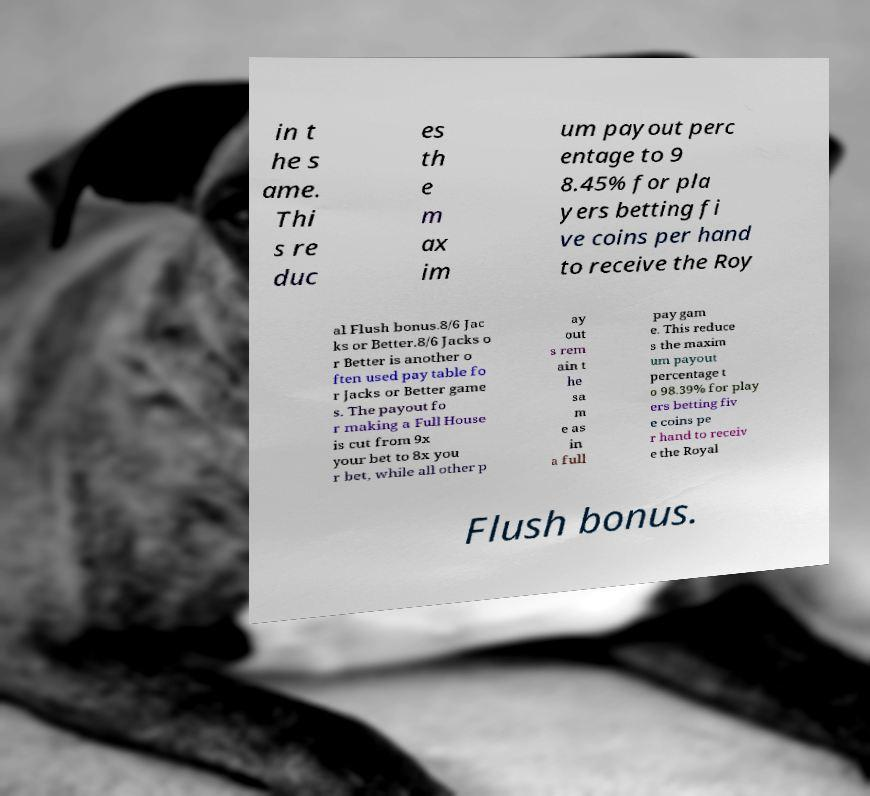Please identify and transcribe the text found in this image. in t he s ame. Thi s re duc es th e m ax im um payout perc entage to 9 8.45% for pla yers betting fi ve coins per hand to receive the Roy al Flush bonus.8/6 Jac ks or Better.8/6 Jacks o r Better is another o ften used pay table fo r Jacks or Better game s. The payout fo r making a Full House is cut from 9x your bet to 8x you r bet, while all other p ay out s rem ain t he sa m e as in a full pay gam e. This reduce s the maxim um payout percentage t o 98.39% for play ers betting fiv e coins pe r hand to receiv e the Royal Flush bonus. 